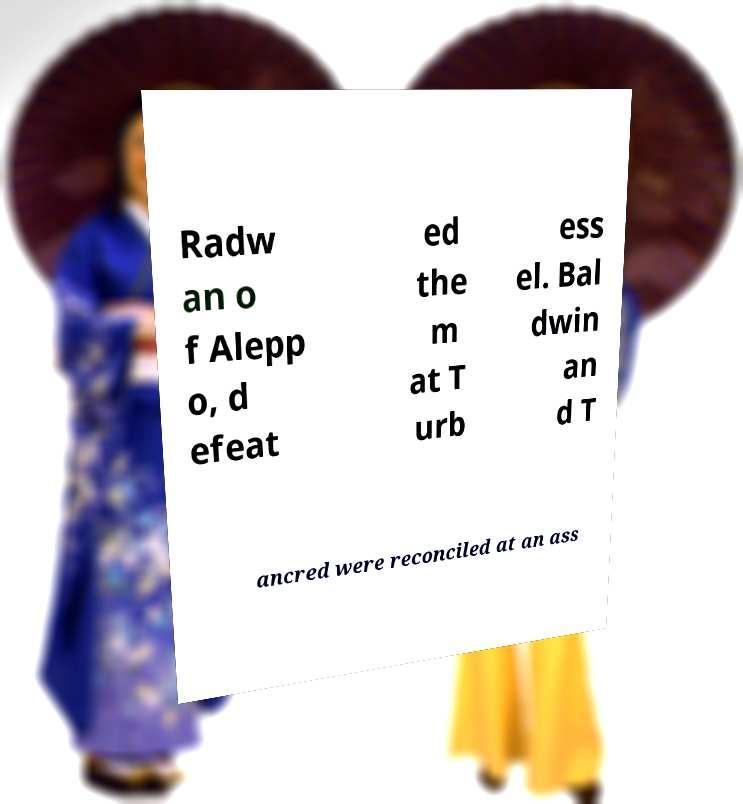There's text embedded in this image that I need extracted. Can you transcribe it verbatim? Radw an o f Alepp o, d efeat ed the m at T urb ess el. Bal dwin an d T ancred were reconciled at an ass 